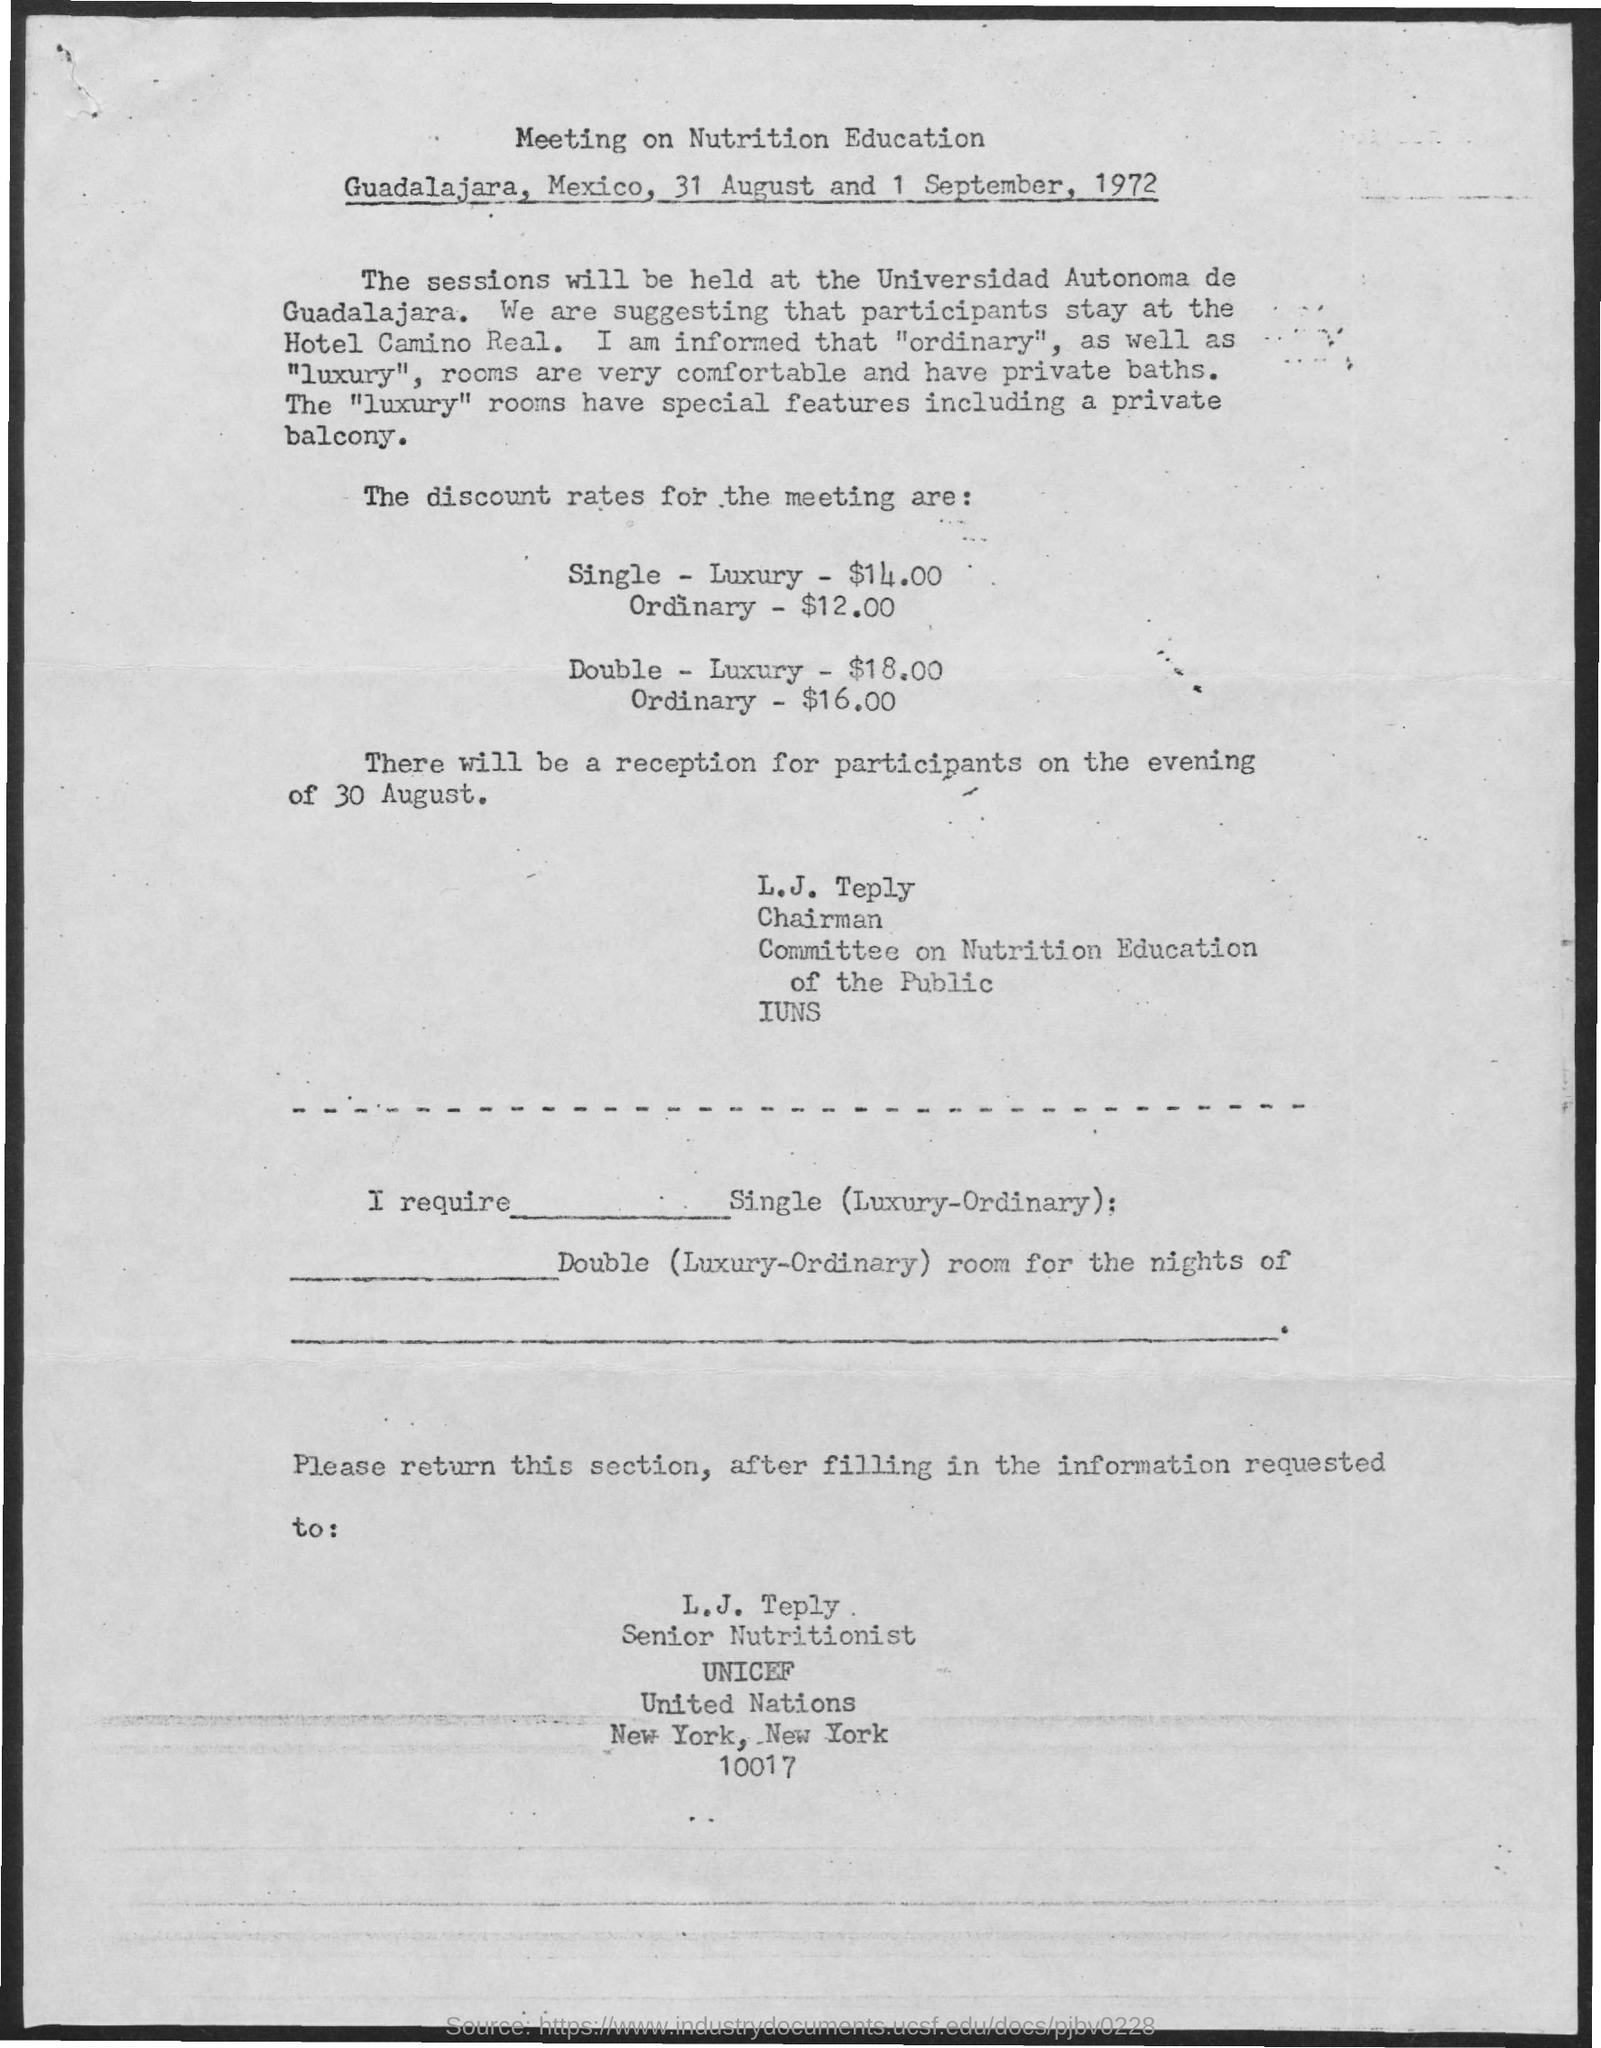When is the meeting on nutrtion education?
Keep it short and to the point. 31 August and 1 September, 1972. Where will the session be held?
Offer a very short reply. Universidad Autonoma de Guadalajara. Where do they suggest the participants to stay?
Your response must be concise. Hotel Camino Real. What is the Discount rate for meeting for Single - Luxury?
Make the answer very short. $14.00. What is the Discount rate for meeting for Single - Ordinary?
Make the answer very short. $12.00. What is the Discount rate for meeting for Double - Luxury?
Offer a terse response. $18.00. What is the Discount rate for meeting for Double - Ordinary?
Your answer should be compact. $16.00. When is the reception for the participants?
Provide a succinct answer. Evening of 30 August. Who should the form be sent to?
Offer a very short reply. L.J. Teply. Where is the location for L. J. Teply?
Ensure brevity in your answer.  New York, New York. 